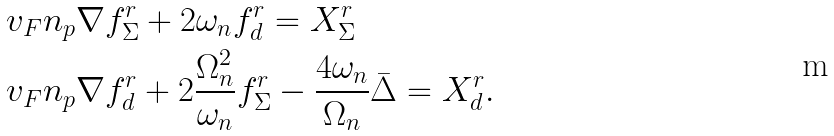Convert formula to latex. <formula><loc_0><loc_0><loc_500><loc_500>& v _ { F } { n _ { p } } \nabla { f } ^ { r } _ { \Sigma } + 2 \omega _ { n } { f } ^ { r } _ { d } = X ^ { r } _ { \Sigma } \\ & v _ { F } { n _ { p } } \nabla { f } ^ { r } _ { d } + 2 \frac { \Omega _ { n } ^ { 2 } } { \omega _ { n } } { f } ^ { r } _ { \Sigma } - \frac { 4 \omega _ { n } } { \Omega _ { n } } \bar { \Delta } = X ^ { r } _ { d } .</formula> 